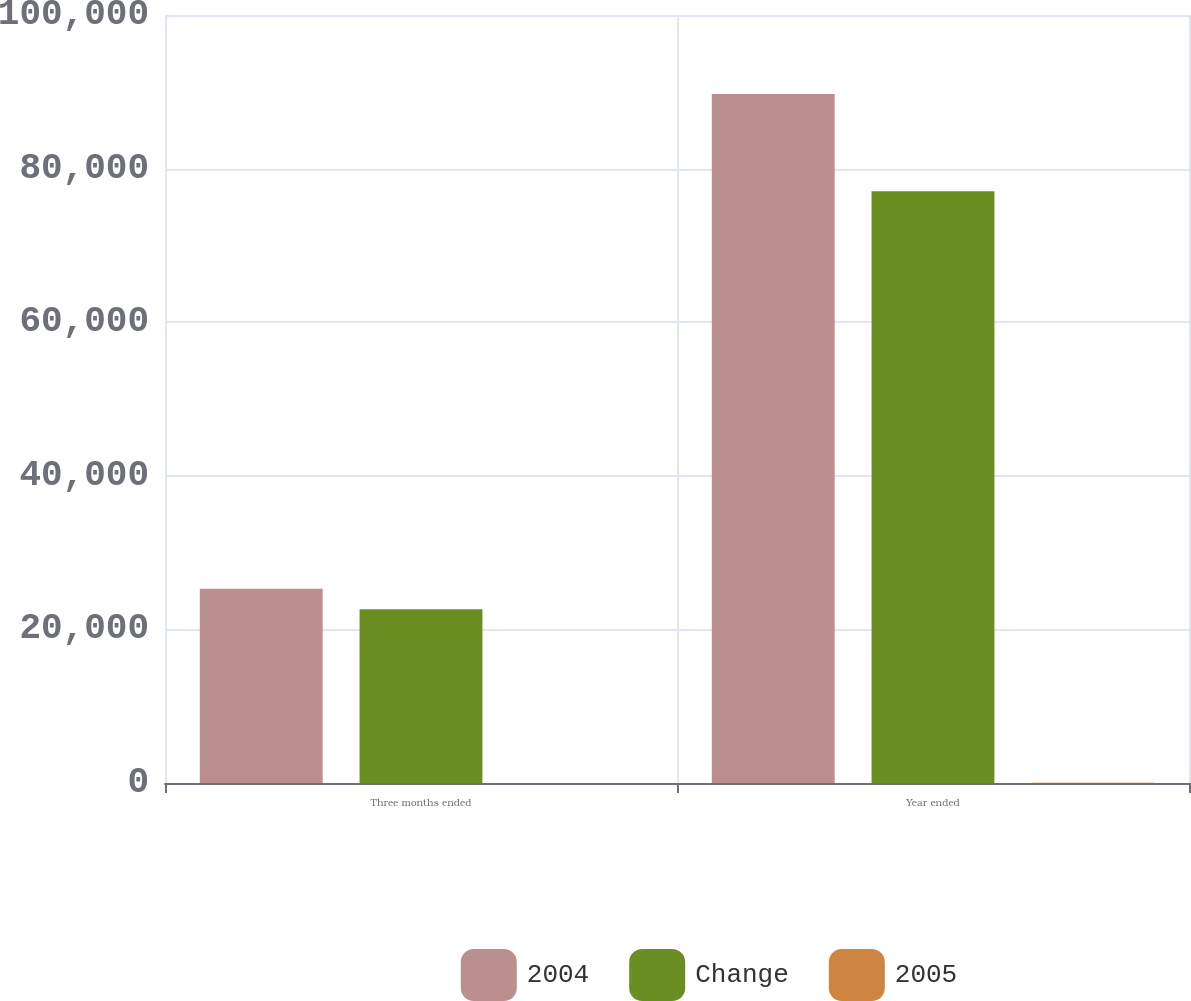Convert chart to OTSL. <chart><loc_0><loc_0><loc_500><loc_500><stacked_bar_chart><ecel><fcel>Three months ended<fcel>Year ended<nl><fcel>2004<fcel>25286<fcel>89707<nl><fcel>Change<fcel>22615<fcel>77062<nl><fcel>2005<fcel>11.8<fcel>16.4<nl></chart> 